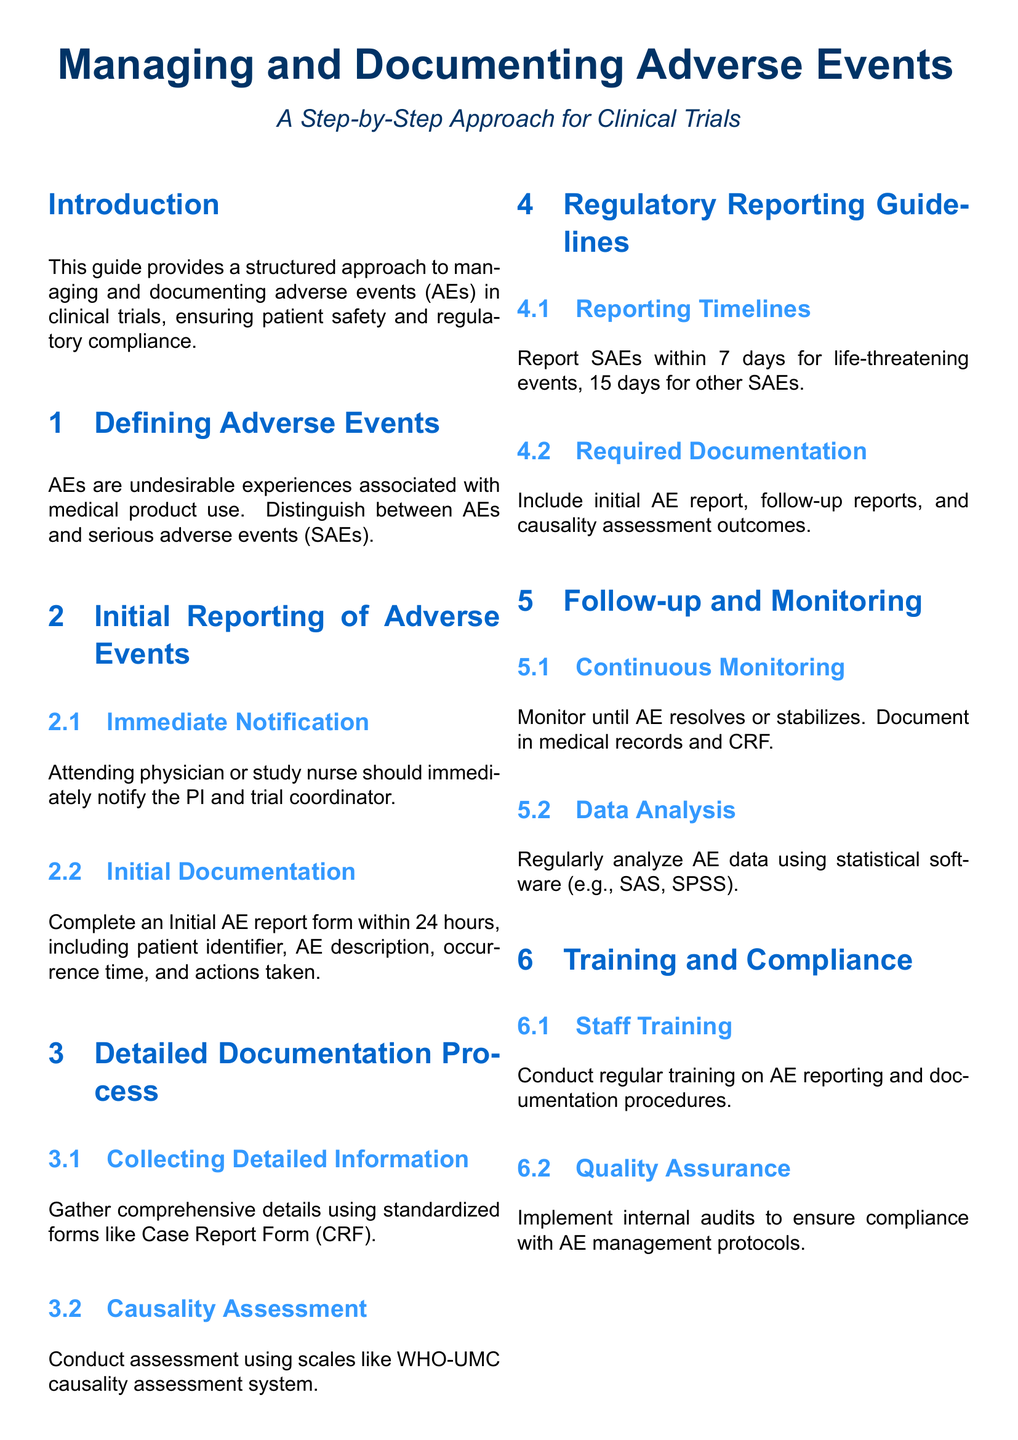What is the main purpose of the guide? The guide aims to provide a structured approach to managing and documenting adverse events in clinical trials, ensuring patient safety and regulatory compliance.
Answer: Managing and documenting adverse events What is required for initial documentation of an adverse event? The initial documentation must include patient identifier, AE description, occurrence time, and actions taken within 24 hours.
Answer: Initial AE report form What is the reporting timeline for serious adverse events that are life-threatening? Life-threatening events must be reported within 7 days according to regulatory reporting guidelines.
Answer: 7 days What system is suggested for causality assessment? The WHO-UMC causality assessment system is recommended for evaluating the relationship between an adverse event and the medical product.
Answer: WHO-UMC How often should staff training on AE reporting be conducted? Regular training should be conducted to ensure compliance with reporting and documentation procedures.
Answer: Regularly What should be monitored until it resolves or stabilizes? Adverse events should be continuously monitored and documented in medical records and case report forms.
Answer: Adverse events What type of analysis should be conducted on adverse event data? Regular analysis of AE data should be performed using statistical software such as SAS or SPSS.
Answer: Data analysis What is the role of the attending physician in the initial reporting of adverse events? The attending physician should immediately notify the Principal Investigator and trial coordinator about the adverse event.
Answer: Immediate Notification 